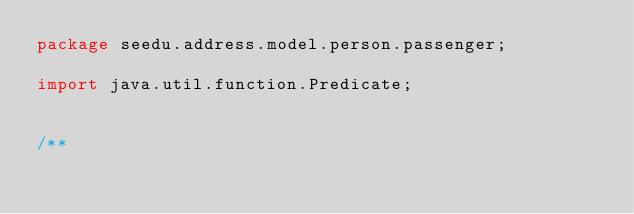<code> <loc_0><loc_0><loc_500><loc_500><_Java_>package seedu.address.model.person.passenger;

import java.util.function.Predicate;


/**</code> 